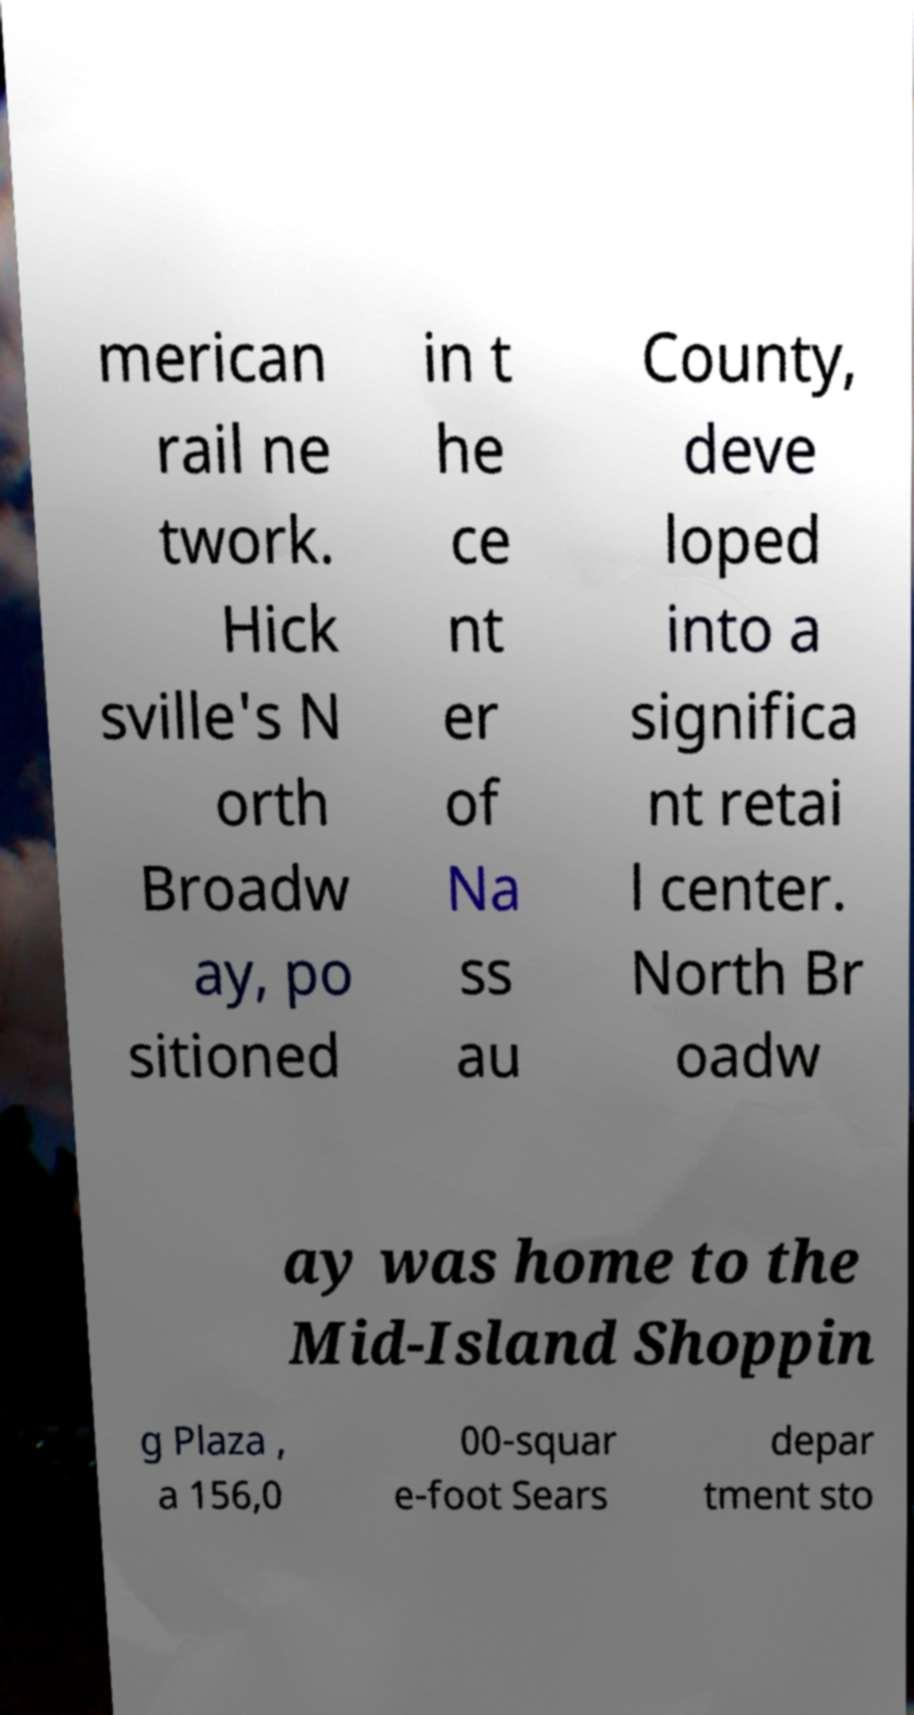Could you assist in decoding the text presented in this image and type it out clearly? merican rail ne twork. Hick sville's N orth Broadw ay, po sitioned in t he ce nt er of Na ss au County, deve loped into a significa nt retai l center. North Br oadw ay was home to the Mid-Island Shoppin g Plaza , a 156,0 00-squar e-foot Sears depar tment sto 